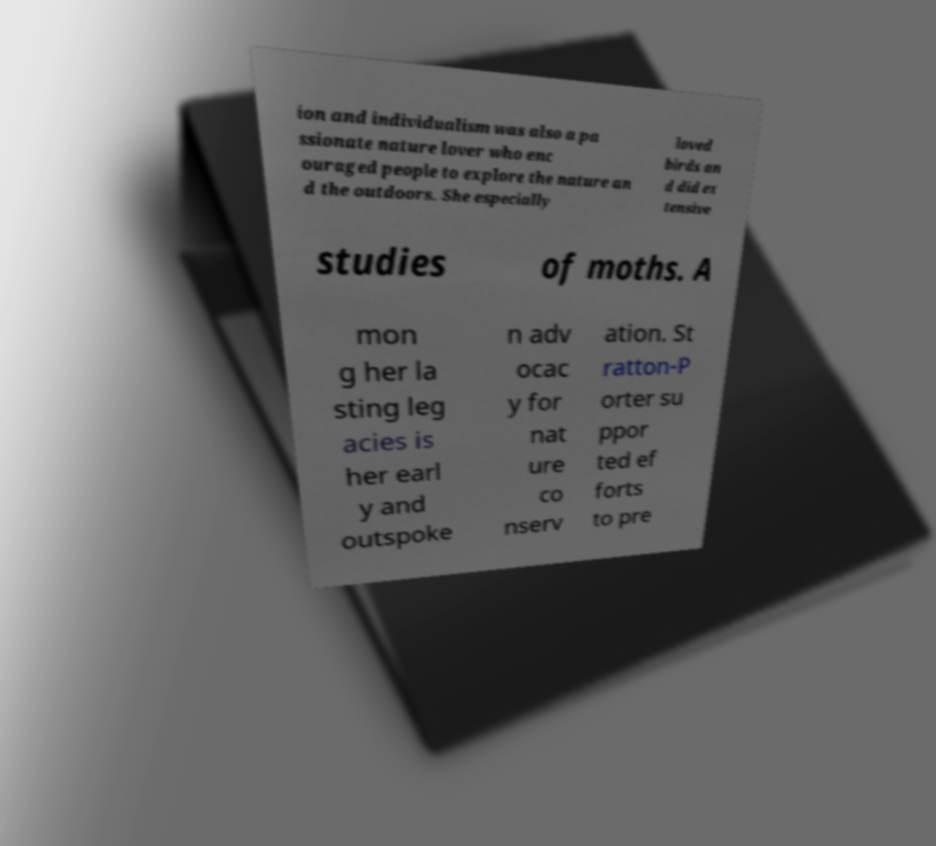Could you assist in decoding the text presented in this image and type it out clearly? ion and individualism was also a pa ssionate nature lover who enc ouraged people to explore the nature an d the outdoors. She especially loved birds an d did ex tensive studies of moths. A mon g her la sting leg acies is her earl y and outspoke n adv ocac y for nat ure co nserv ation. St ratton-P orter su ppor ted ef forts to pre 